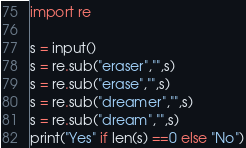Convert code to text. <code><loc_0><loc_0><loc_500><loc_500><_Python_>import re

s = input()
s = re.sub("eraser","",s)
s = re.sub("erase","",s)
s = re.sub("dreamer","",s)
s = re.sub("dream","",s)
print("Yes" if len(s) ==0 else "No")

</code> 